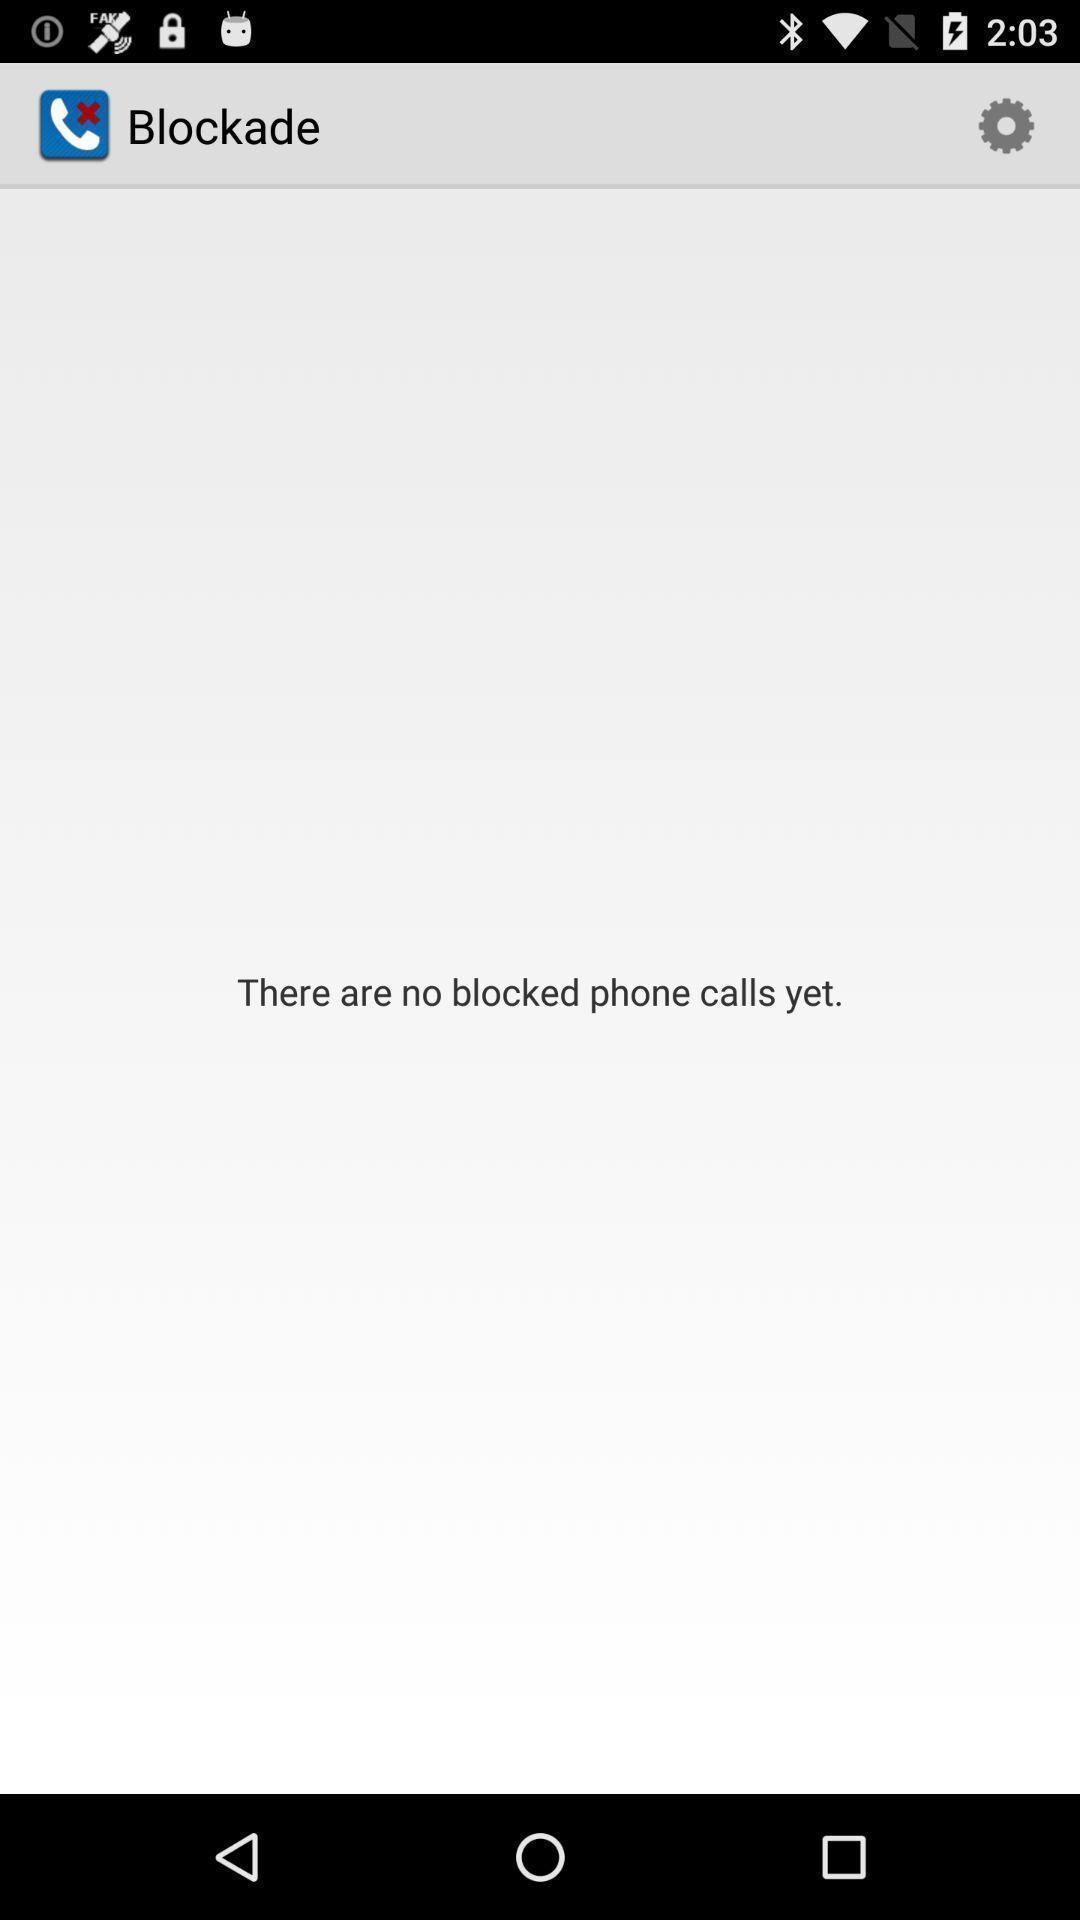Describe the visual elements of this screenshot. Page displaying the empty blocklist of a calling app. 